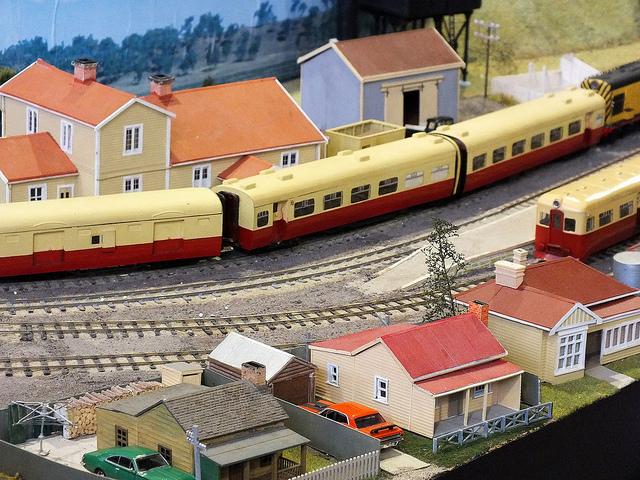What color is the train?
Write a very short answer. Yellow and red. Is this real or fake?
Give a very brief answer. Fake. What do we call this sort of construct?
Concise answer only. Model. 